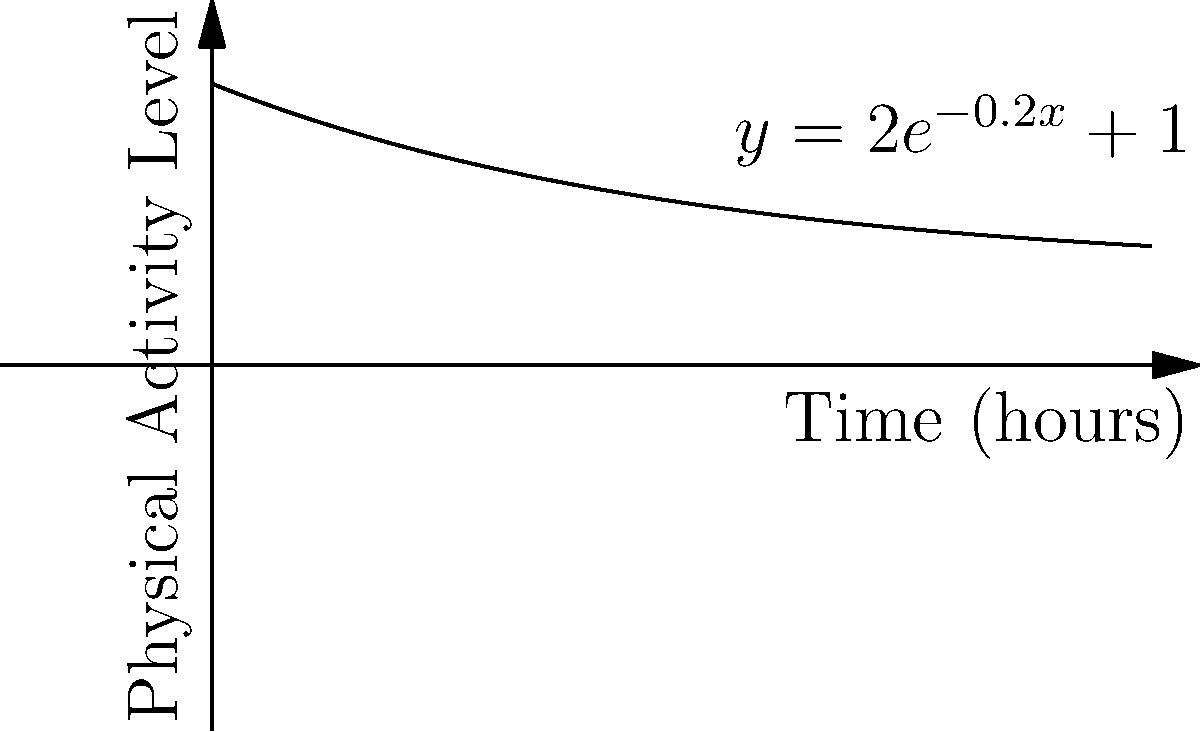A health study tracked the physical activity levels of students over time after implementing a digital detox program. The activity level (in arbitrary units) as a function of time (in hours) since the program began is modeled by the function $y = 2e^{-0.2x} + 1$. Find the volume of the solid formed by rotating this curve around the x-axis from $x = 0$ to $x = 10$ hours. Use $\pi \approx 3.14$. To find the volume of the solid formed by rotation around the x-axis, we use the washer method:

1) The volume is given by the integral: $V = \pi \int_0^{10} [f(x)]^2 dx$

2) Substitute the function: $V = \pi \int_0^{10} (2e^{-0.2x} + 1)^2 dx$

3) Expand the squared term:
   $V = \pi \int_0^{10} (4e^{-0.4x} + 4e^{-0.2x} + 1) dx$

4) Integrate each term:
   $V = \pi [-10e^{-0.4x} - 20e^{-0.2x} + x]_0^{10}$

5) Evaluate the integral:
   $V = \pi [(-10e^{-4} - 20e^{-2} + 10) - (-10 - 20 + 0)]$
   $V = \pi [(-10(0.0183) - 20(0.1353) + 10) - (-30)]$
   $V = \pi [(-0.183 - 2.706 + 10) + 30]$
   $V = \pi [37.111]$

6) Multiply by $\pi$:
   $V = 116.53$ (rounded to two decimal places)
Answer: 116.53 cubic units 